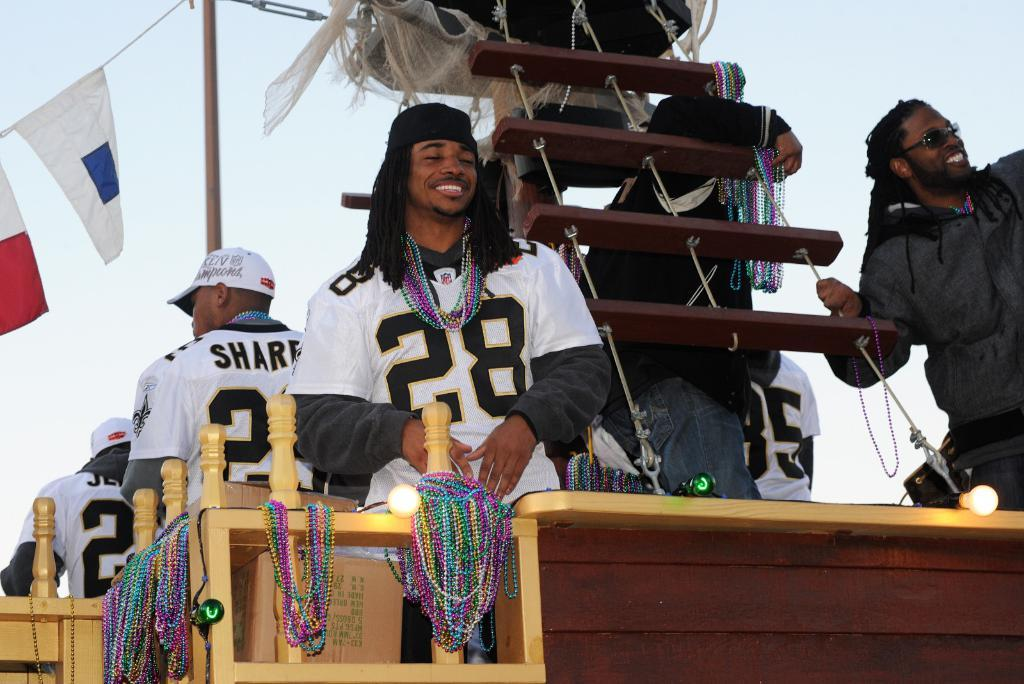What can be seen in the image involving people? There are persons standing in the image. What type of objects are present in the image that are typically used for decoration or celebration? There are beads, flags, and poles in the image. What are the ropes used for in the image? The ropes are likely used to hang or support the flags and other decorations. What is visible in the background of the image? The sky is visible in the image. What type of jeans can be seen on the mountain in the image? There is no mountain or jeans present in the image. How does the winter affect the scene in the image? The provided facts do not mention any season or weather conditions, so it is impossible to determine the effect of winter on the scene. 